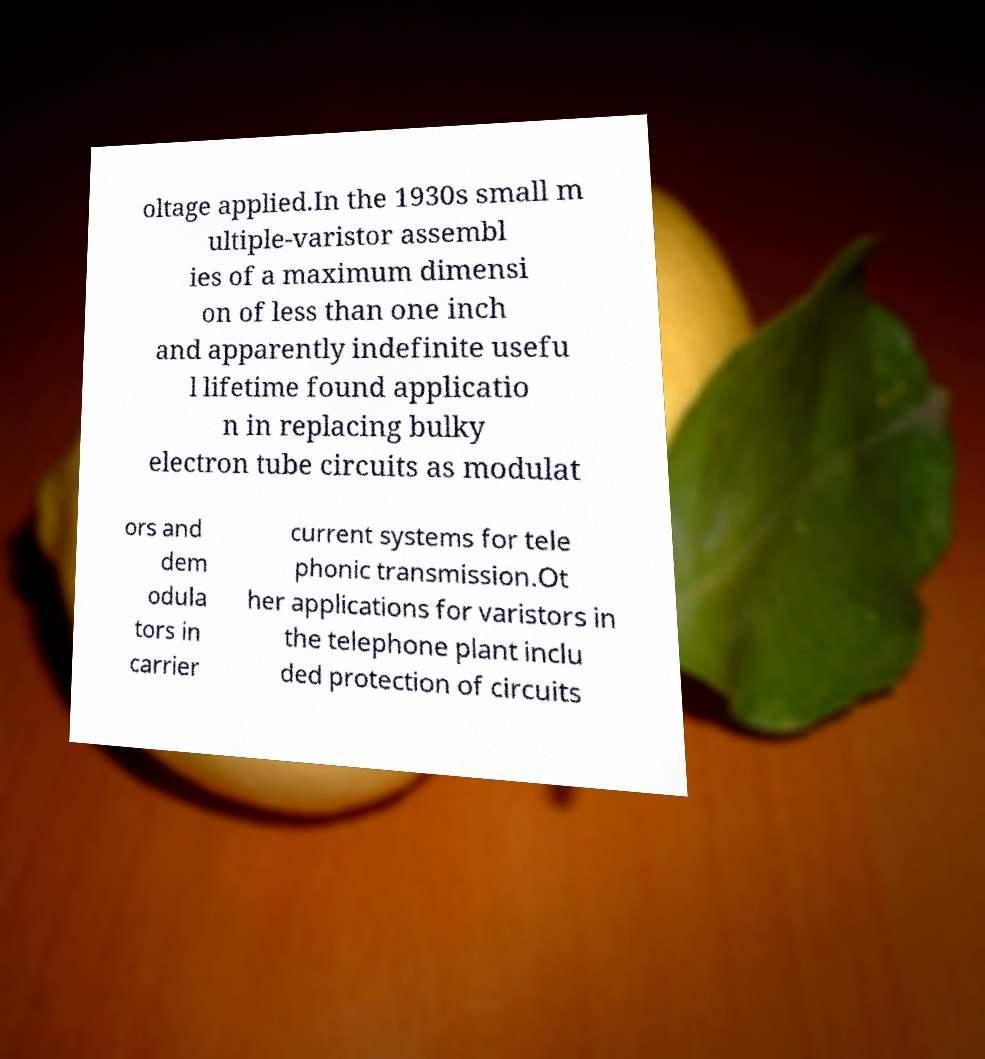For documentation purposes, I need the text within this image transcribed. Could you provide that? oltage applied.In the 1930s small m ultiple-varistor assembl ies of a maximum dimensi on of less than one inch and apparently indefinite usefu l lifetime found applicatio n in replacing bulky electron tube circuits as modulat ors and dem odula tors in carrier current systems for tele phonic transmission.Ot her applications for varistors in the telephone plant inclu ded protection of circuits 